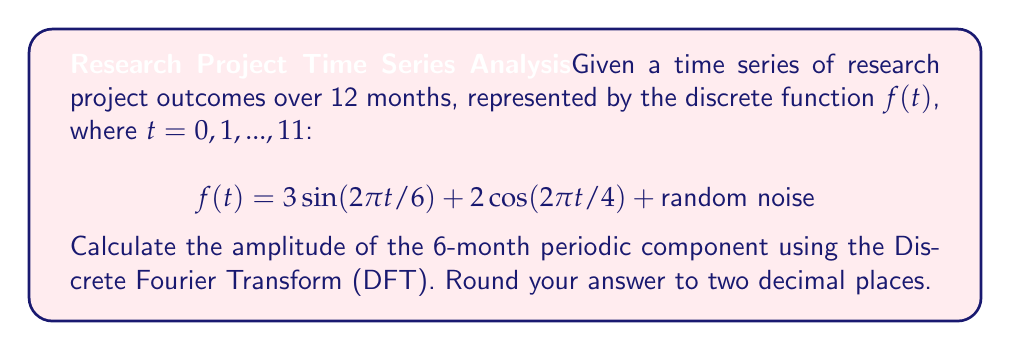Teach me how to tackle this problem. To solve this problem, we'll follow these steps:

1) The Discrete Fourier Transform (DFT) of a sequence $x[n]$ of length N is given by:

   $$X[k] = \sum_{n=0}^{N-1} x[n] e^{-i2\pi kn/N}$$

2) In our case, $N = 12$ (12 months), and we're interested in the 6-month period component, which corresponds to $k = 2$ (because $12/6 = 2$).

3) The 6-month periodic component in the given function is $3 \sin(2\pi t/6)$. Let's call this component $g(t)$.

4) We need to calculate:

   $$X[2] = \sum_{t=0}^{11} g(t) e^{-i2\pi 2t/12}$$

5) Expanding this:

   $$X[2] = \sum_{t=0}^{11} 3 \sin(2\pi t/6) (\cos(-\pi t/3) + i \sin(-\pi t/3))$$

6) Using the trigonometric identity $\sin A \cos B = \frac{1}{2}[\sin(A-B) + \sin(A+B)]$ and $\sin A \sin B = -\frac{1}{2}[\cos(A-B) - \cos(A+B)]$, we get:

   $$X[2] = \frac{3}{2} \sum_{t=0}^{11} [\sin(\pi t/3) - i \cos(\pi t/3)] = \frac{3}{2} (6 - 6i) = 9 - 9i$$

7) The amplitude of this component is given by the magnitude of $X[2]$:

   $$|X[2]| = \sqrt{9^2 + 9^2} = 9\sqrt{2} \approx 12.73$$

8) However, we need to divide this by $N/2 = 6$ to get the actual amplitude:

   $$\text{Amplitude} = \frac{9\sqrt{2}}{6} = \frac{3\sqrt{2}}{2} \approx 2.12$$
Answer: $2.12$ 